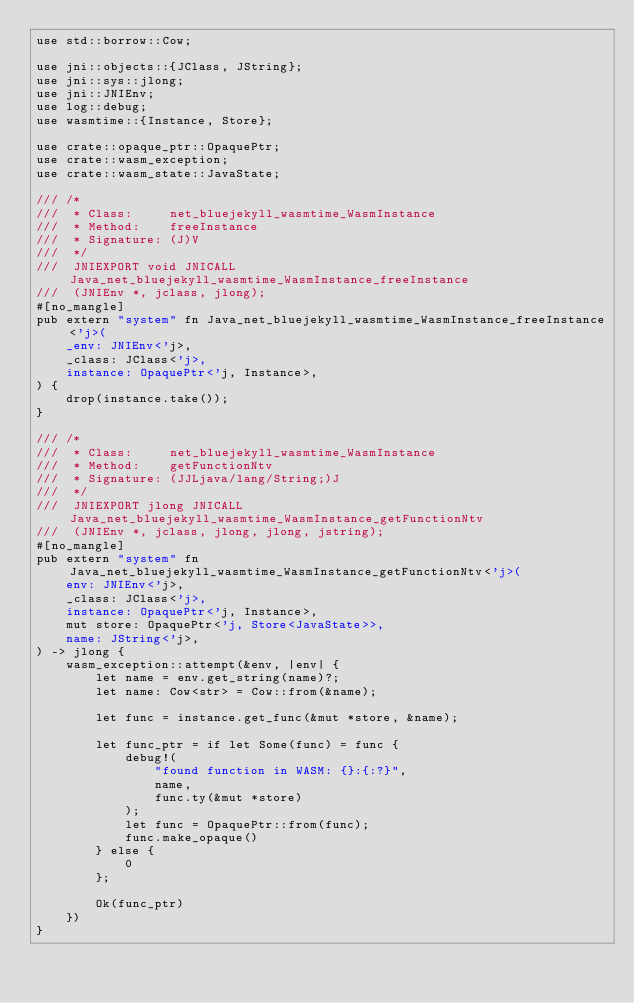Convert code to text. <code><loc_0><loc_0><loc_500><loc_500><_Rust_>use std::borrow::Cow;

use jni::objects::{JClass, JString};
use jni::sys::jlong;
use jni::JNIEnv;
use log::debug;
use wasmtime::{Instance, Store};

use crate::opaque_ptr::OpaquePtr;
use crate::wasm_exception;
use crate::wasm_state::JavaState;

/// /*
///  * Class:     net_bluejekyll_wasmtime_WasmInstance
///  * Method:    freeInstance
///  * Signature: (J)V
///  */
///  JNIEXPORT void JNICALL Java_net_bluejekyll_wasmtime_WasmInstance_freeInstance
///  (JNIEnv *, jclass, jlong);
#[no_mangle]
pub extern "system" fn Java_net_bluejekyll_wasmtime_WasmInstance_freeInstance<'j>(
    _env: JNIEnv<'j>,
    _class: JClass<'j>,
    instance: OpaquePtr<'j, Instance>,
) {
    drop(instance.take());
}

/// /*
///  * Class:     net_bluejekyll_wasmtime_WasmInstance
///  * Method:    getFunctionNtv
///  * Signature: (JJLjava/lang/String;)J
///  */
///  JNIEXPORT jlong JNICALL Java_net_bluejekyll_wasmtime_WasmInstance_getFunctionNtv
///  (JNIEnv *, jclass, jlong, jlong, jstring);
#[no_mangle]
pub extern "system" fn Java_net_bluejekyll_wasmtime_WasmInstance_getFunctionNtv<'j>(
    env: JNIEnv<'j>,
    _class: JClass<'j>,
    instance: OpaquePtr<'j, Instance>,
    mut store: OpaquePtr<'j, Store<JavaState>>,
    name: JString<'j>,
) -> jlong {
    wasm_exception::attempt(&env, |env| {
        let name = env.get_string(name)?;
        let name: Cow<str> = Cow::from(&name);

        let func = instance.get_func(&mut *store, &name);

        let func_ptr = if let Some(func) = func {
            debug!(
                "found function in WASM: {}:{:?}",
                name,
                func.ty(&mut *store)
            );
            let func = OpaquePtr::from(func);
            func.make_opaque()
        } else {
            0
        };

        Ok(func_ptr)
    })
}
</code> 